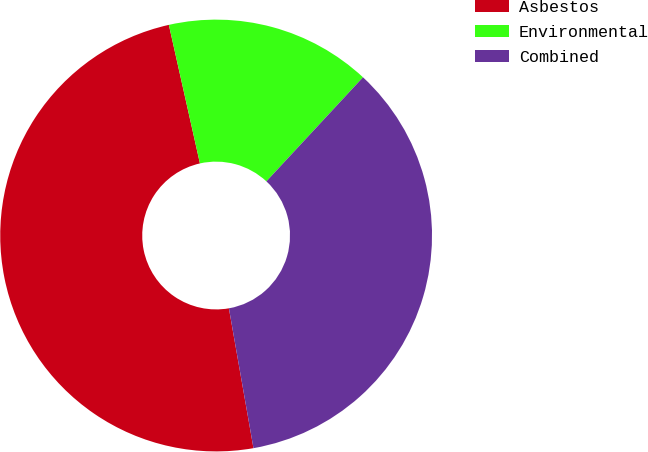Convert chart. <chart><loc_0><loc_0><loc_500><loc_500><pie_chart><fcel>Asbestos<fcel>Environmental<fcel>Combined<nl><fcel>49.25%<fcel>15.42%<fcel>35.32%<nl></chart> 